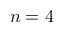Convert formula to latex. <formula><loc_0><loc_0><loc_500><loc_500>n = 4</formula> 